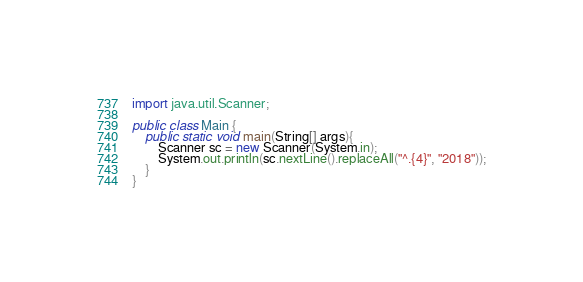Convert code to text. <code><loc_0><loc_0><loc_500><loc_500><_Java_>import java.util.Scanner;

public class Main {
	public static void main(String[] args){
		Scanner sc = new Scanner(System.in);
		System.out.println(sc.nextLine().replaceAll("^.{4}", "2018"));
	}
}</code> 